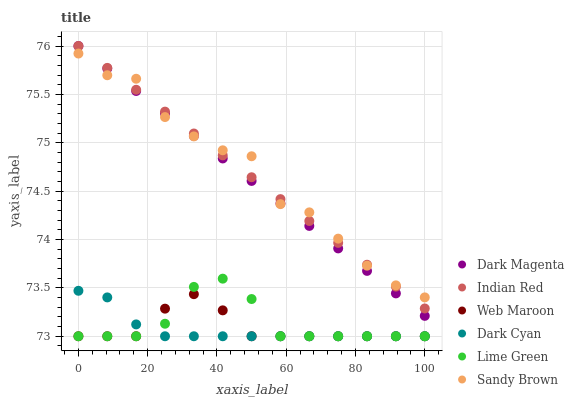Does Dark Cyan have the minimum area under the curve?
Answer yes or no. Yes. Does Sandy Brown have the maximum area under the curve?
Answer yes or no. Yes. Does Web Maroon have the minimum area under the curve?
Answer yes or no. No. Does Web Maroon have the maximum area under the curve?
Answer yes or no. No. Is Indian Red the smoothest?
Answer yes or no. Yes. Is Sandy Brown the roughest?
Answer yes or no. Yes. Is Web Maroon the smoothest?
Answer yes or no. No. Is Web Maroon the roughest?
Answer yes or no. No. Does Web Maroon have the lowest value?
Answer yes or no. Yes. Does Sandy Brown have the lowest value?
Answer yes or no. No. Does Indian Red have the highest value?
Answer yes or no. Yes. Does Sandy Brown have the highest value?
Answer yes or no. No. Is Lime Green less than Indian Red?
Answer yes or no. Yes. Is Dark Magenta greater than Lime Green?
Answer yes or no. Yes. Does Dark Cyan intersect Web Maroon?
Answer yes or no. Yes. Is Dark Cyan less than Web Maroon?
Answer yes or no. No. Is Dark Cyan greater than Web Maroon?
Answer yes or no. No. Does Lime Green intersect Indian Red?
Answer yes or no. No. 